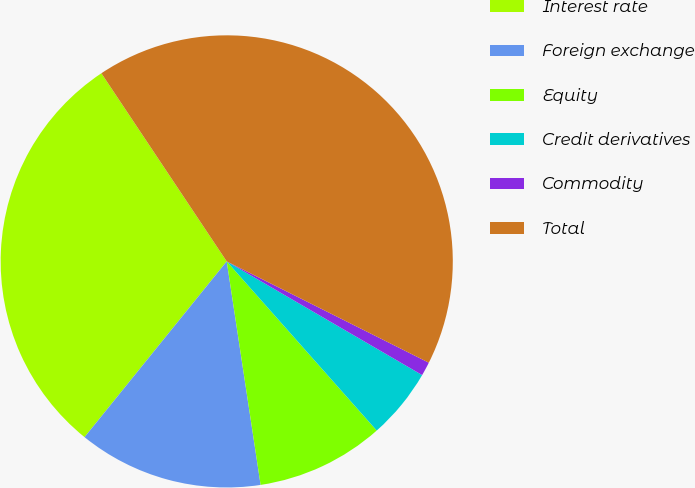Convert chart. <chart><loc_0><loc_0><loc_500><loc_500><pie_chart><fcel>Interest rate<fcel>Foreign exchange<fcel>Equity<fcel>Credit derivatives<fcel>Commodity<fcel>Total<nl><fcel>29.82%<fcel>13.22%<fcel>9.15%<fcel>5.07%<fcel>0.99%<fcel>41.75%<nl></chart> 